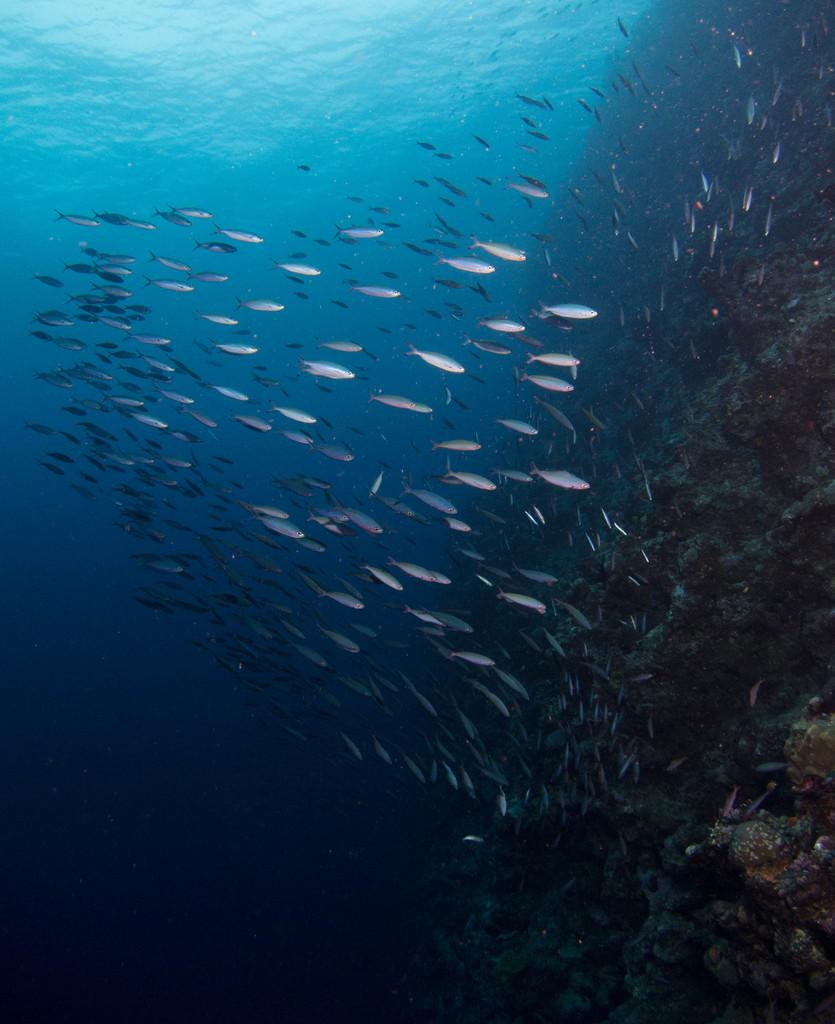What type of animals can be seen in the image? There are fishes in the water. What can be found on the right side of the image? There are rocks on the right side of the image. What type of alley can be seen in the image? There is no alley present in the image; it features fishes in the water and rocks on the right side. 